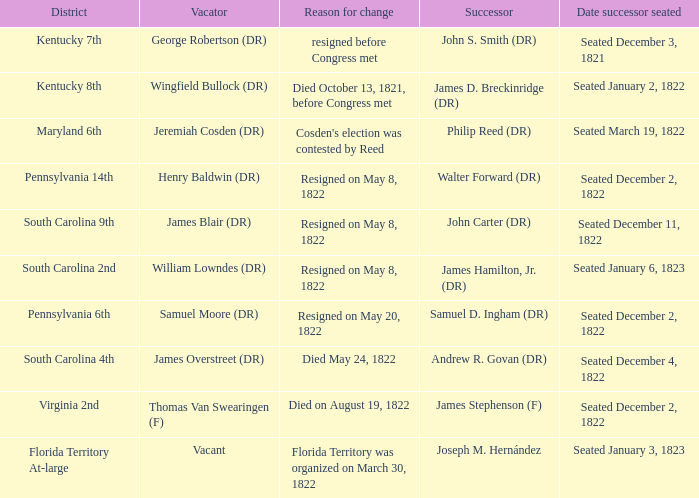Who is the heir when florida territory at-large is the district? Joseph M. Hernández. 